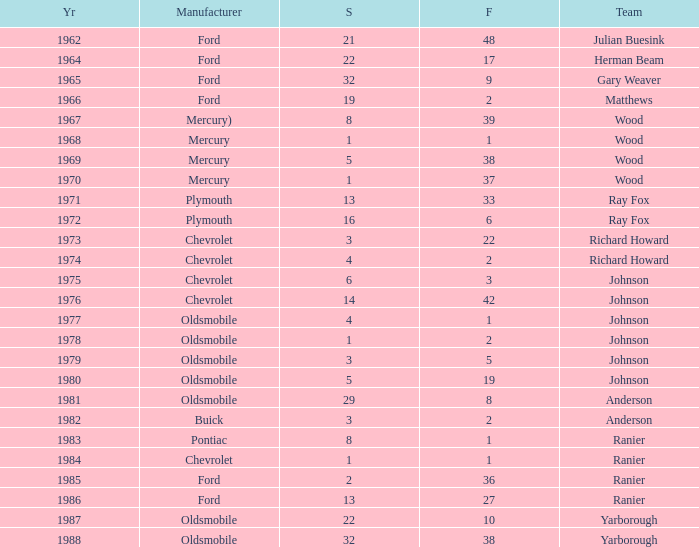What is the smallest finish time for a race where start was less than 3, buick was the manufacturer, and the race was held after 1978? None. 